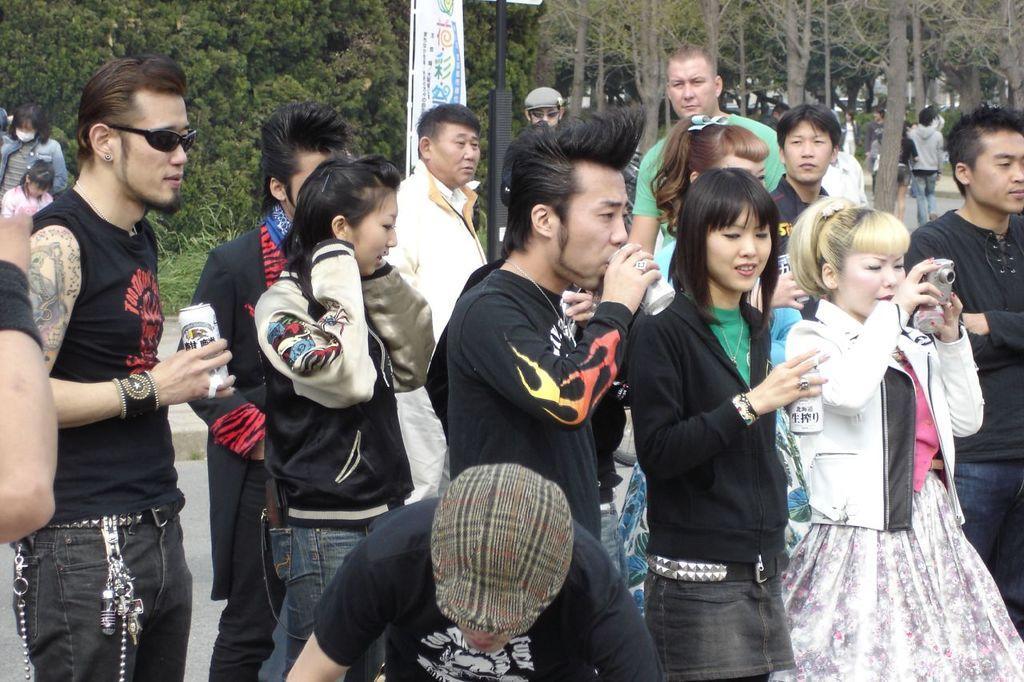Describe this image in one or two sentences. In this image I see number of people in which these 3 of them are holding cans in their hands and this woman is holding a camera in her hands. In the background I see the trees and I see the pole over here and I see few more people over here. 